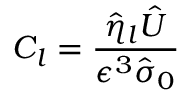<formula> <loc_0><loc_0><loc_500><loc_500>C _ { l } = \frac { \hat { \eta } _ { l } \hat { U } } { \epsilon ^ { 3 } \hat { \sigma } _ { 0 } }</formula> 